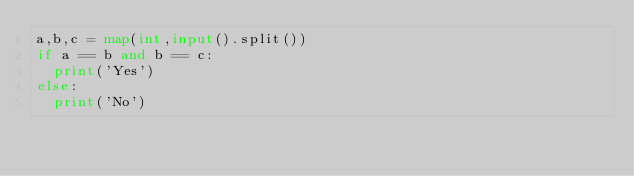<code> <loc_0><loc_0><loc_500><loc_500><_Python_>a,b,c = map(int,input().split())
if a == b and b == c:
  print('Yes')
else:
  print('No')</code> 